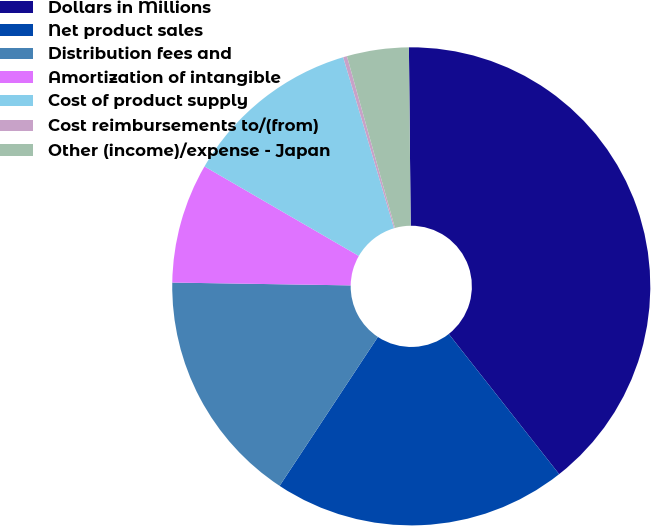Convert chart to OTSL. <chart><loc_0><loc_0><loc_500><loc_500><pie_chart><fcel>Dollars in Millions<fcel>Net product sales<fcel>Distribution fees and<fcel>Amortization of intangible<fcel>Cost of product supply<fcel>Cost reimbursements to/(from)<fcel>Other (income)/expense - Japan<nl><fcel>39.54%<fcel>19.9%<fcel>15.97%<fcel>8.11%<fcel>12.04%<fcel>0.26%<fcel>4.18%<nl></chart> 